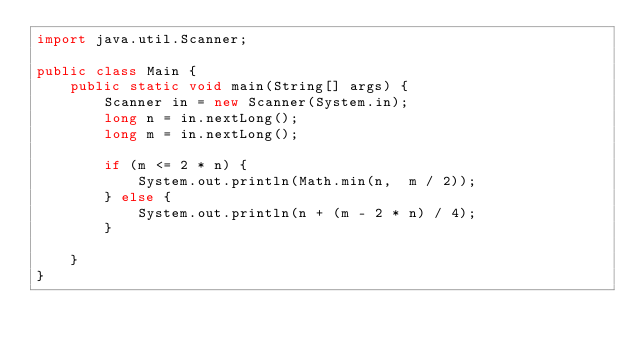<code> <loc_0><loc_0><loc_500><loc_500><_Java_>import java.util.Scanner;

public class Main {
    public static void main(String[] args) {
        Scanner in = new Scanner(System.in);
        long n = in.nextLong();
        long m = in.nextLong();

        if (m <= 2 * n) {
            System.out.println(Math.min(n,  m / 2));
        } else {
            System.out.println(n + (m - 2 * n) / 4);
        }

    }
}
</code> 